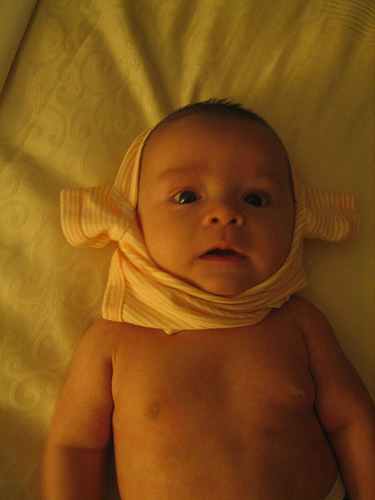<image>
Is there a shirt above the baby? No. The shirt is not positioned above the baby. The vertical arrangement shows a different relationship. Is there a baby on the bed? Yes. Looking at the image, I can see the baby is positioned on top of the bed, with the bed providing support. Where is the blanket in relation to the baby? Is it on the baby? No. The blanket is not positioned on the baby. They may be near each other, but the blanket is not supported by or resting on top of the baby. 